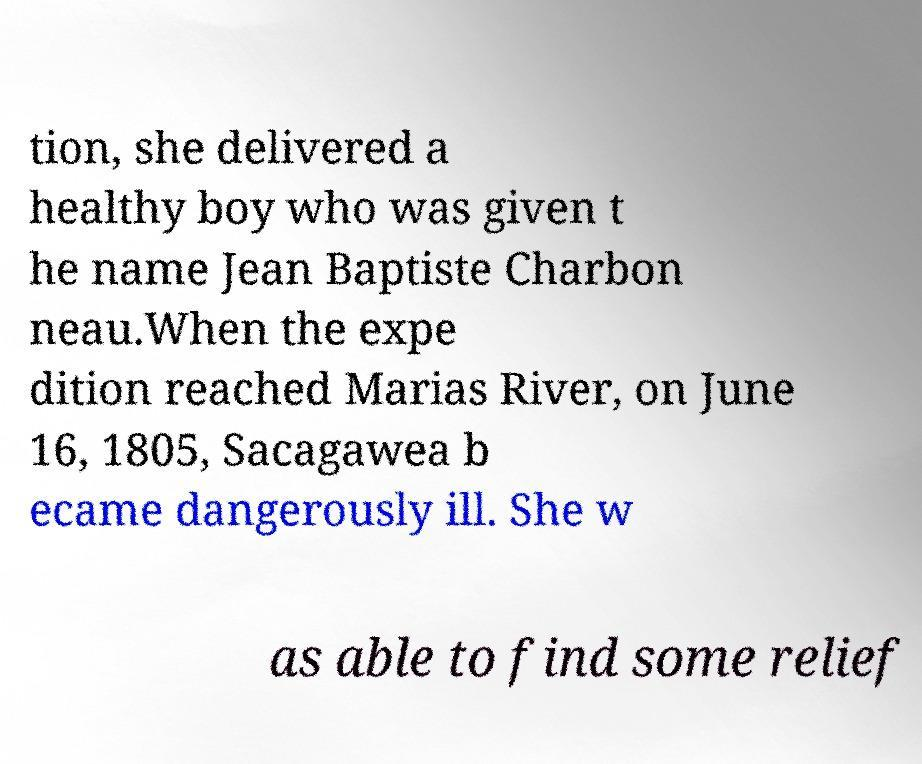There's text embedded in this image that I need extracted. Can you transcribe it verbatim? tion, she delivered a healthy boy who was given t he name Jean Baptiste Charbon neau.When the expe dition reached Marias River, on June 16, 1805, Sacagawea b ecame dangerously ill. She w as able to find some relief 